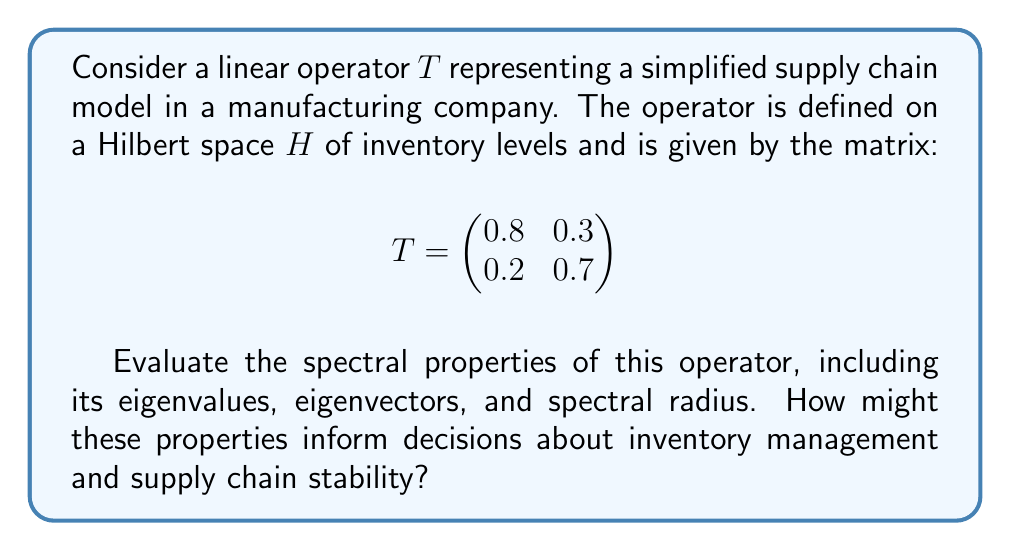Help me with this question. To evaluate the spectral properties of the linear operator $T$, we need to follow these steps:

1) Find the eigenvalues:
   The characteristic equation is given by $\det(T - \lambda I) = 0$
   
   $$\det\begin{pmatrix}
   0.8 - \lambda & 0.3 \\
   0.2 & 0.7 - \lambda
   \end{pmatrix} = 0$$
   
   $(0.8 - \lambda)(0.7 - \lambda) - 0.06 = 0$
   
   $\lambda^2 - 1.5\lambda + 0.5 = 0$
   
   Solving this quadratic equation:
   $\lambda_1 = 1$ and $\lambda_2 = 0.5$

2) Find the eigenvectors:
   For $\lambda_1 = 1$:
   $(T - I)v = 0$
   
   $$\begin{pmatrix}
   -0.2 & 0.3 \\
   0.2 & -0.3
   \end{pmatrix}\begin{pmatrix}
   v_1 \\ v_2
   \end{pmatrix} = \begin{pmatrix}
   0 \\ 0
   \end{pmatrix}$$
   
   This gives us $v_1 = 3$ and $v_2 = 2$. So, $v_1 = (3, 2)^T$
   
   For $\lambda_2 = 0.5$:
   $(T - 0.5I)v = 0$
   
   $$\begin{pmatrix}
   0.3 & 0.3 \\
   0.2 & 0.2
   \end{pmatrix}\begin{pmatrix}
   v_1 \\ v_2
   \end{pmatrix} = \begin{pmatrix}
   0 \\ 0
   \end{pmatrix}$$
   
   This gives us $v_1 = -1$ and $v_2 = 1$. So, $v_2 = (-1, 1)^T$

3) The spectral radius is the maximum absolute value of the eigenvalues:
   $\rho(T) = \max(|\lambda_1|, |\lambda_2|) = \max(1, 0.5) = 1$

Interpretation for supply chain management:

1) The eigenvalues (1 and 0.5) represent the rates at which different components of the inventory system grow or decay over time.

2) The eigenvector associated with $\lambda_1 = 1$ (3, 2) represents a steady-state inventory distribution that remains unchanged under the operation of $T$.

3) The eigenvector associated with $\lambda_2 = 0.5$ (-1, 1) represents a component of the inventory that decays over time.

4) The spectral radius of 1 indicates that the system is marginally stable. In supply chain terms, this suggests that inventory levels will not grow unboundedly over time, but they may not naturally decrease either.

These properties can inform inventory management strategies:
- The steady-state eigenvector suggests an optimal ratio of inventory levels to maintain.
- The decaying component can be used to identify which parts of the inventory naturally tend to decrease.
- The marginal stability indicates that active management is needed to reduce inventory levels if desired, as the system won't naturally drive inventories down.
Answer: The spectral properties of the operator $T$ are:

Eigenvalues: $\lambda_1 = 1$, $\lambda_2 = 0.5$
Eigenvectors: $v_1 = (3, 2)^T$, $v_2 = (-1, 1)^T$
Spectral radius: $\rho(T) = 1$

These properties indicate a marginally stable supply chain system with a steady-state inventory distribution and a decaying component, suggesting the need for active inventory management to maintain optimal levels and ratios. 